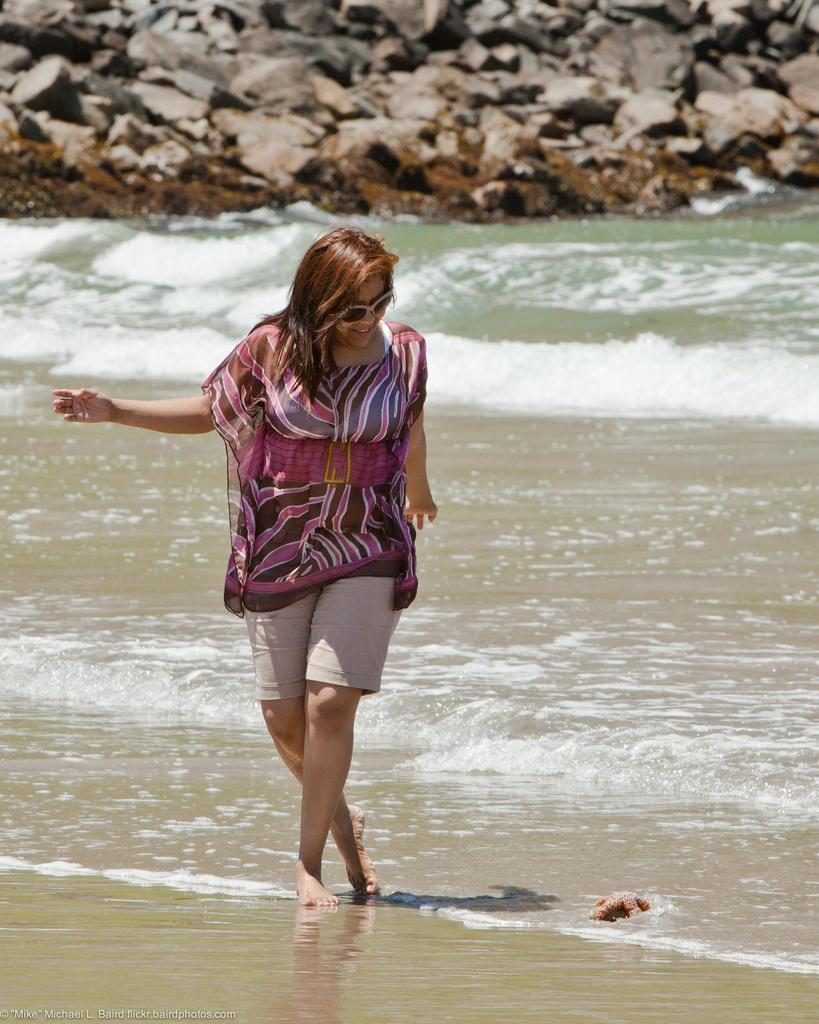Who is present in the image? There is a woman in the image. What is the woman doing in the image? The woman is walking in the image. What is the woman's facial expression in the image? The woman is smiling in the image. What type of environment can be seen in the image? There is water and stones visible in the image. How many eggs are being sold by the woman in the image? There is no indication of eggs or any sales activity in the image. 